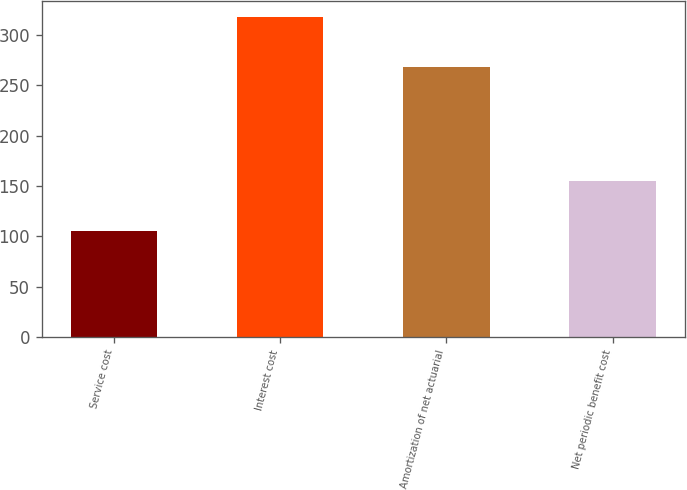<chart> <loc_0><loc_0><loc_500><loc_500><bar_chart><fcel>Service cost<fcel>Interest cost<fcel>Amortization of net actuarial<fcel>Net periodic benefit cost<nl><fcel>105<fcel>318<fcel>268<fcel>155<nl></chart> 